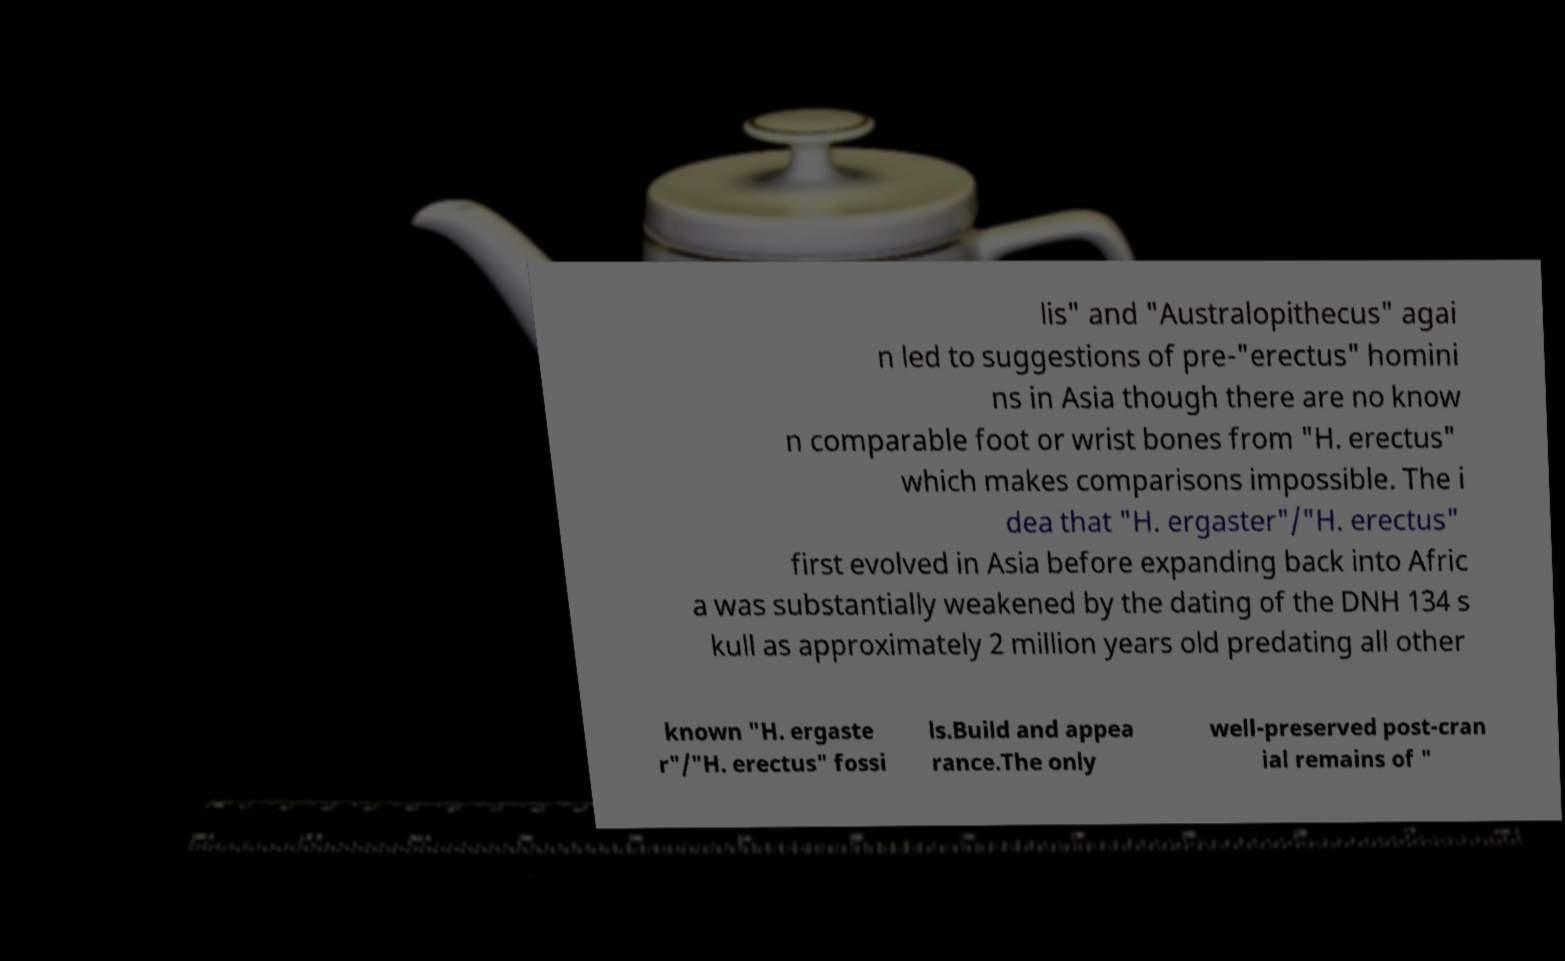Can you accurately transcribe the text from the provided image for me? lis" and "Australopithecus" agai n led to suggestions of pre-"erectus" homini ns in Asia though there are no know n comparable foot or wrist bones from "H. erectus" which makes comparisons impossible. The i dea that "H. ergaster"/"H. erectus" first evolved in Asia before expanding back into Afric a was substantially weakened by the dating of the DNH 134 s kull as approximately 2 million years old predating all other known "H. ergaste r"/"H. erectus" fossi ls.Build and appea rance.The only well-preserved post-cran ial remains of " 